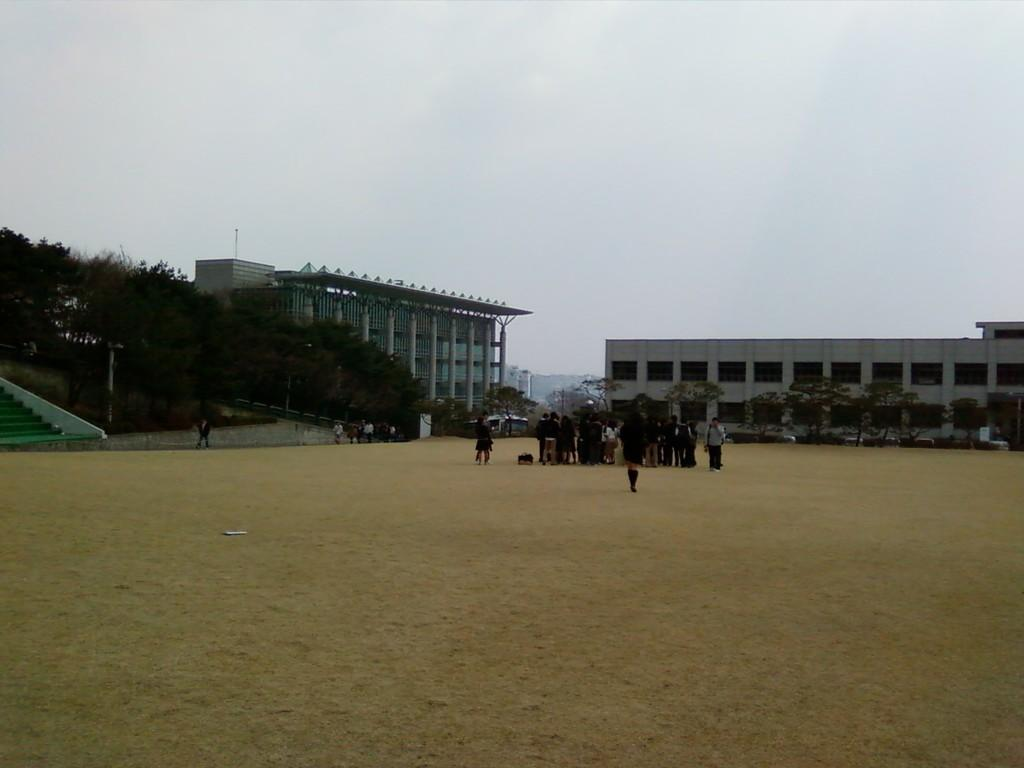What are the people in the image doing? The people in the image are standing on the ground. What can be seen on the left side of the image? There are stairs on the left side of the image. What is visible in the background of the image? Trees, buildings, and the sky are visible in the background of the image. What is the price of the stove in the image? There is no stove present in the image, so it is not possible to determine its price. 